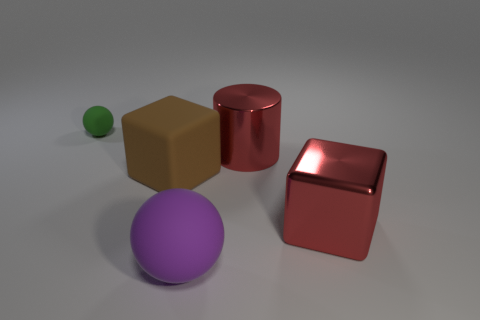Add 3 large red objects. How many objects exist? 8 Subtract all blocks. How many objects are left? 3 Add 3 metallic cubes. How many metallic cubes exist? 4 Subtract 0 yellow cylinders. How many objects are left? 5 Subtract all large purple cylinders. Subtract all large rubber things. How many objects are left? 3 Add 1 big rubber blocks. How many big rubber blocks are left? 2 